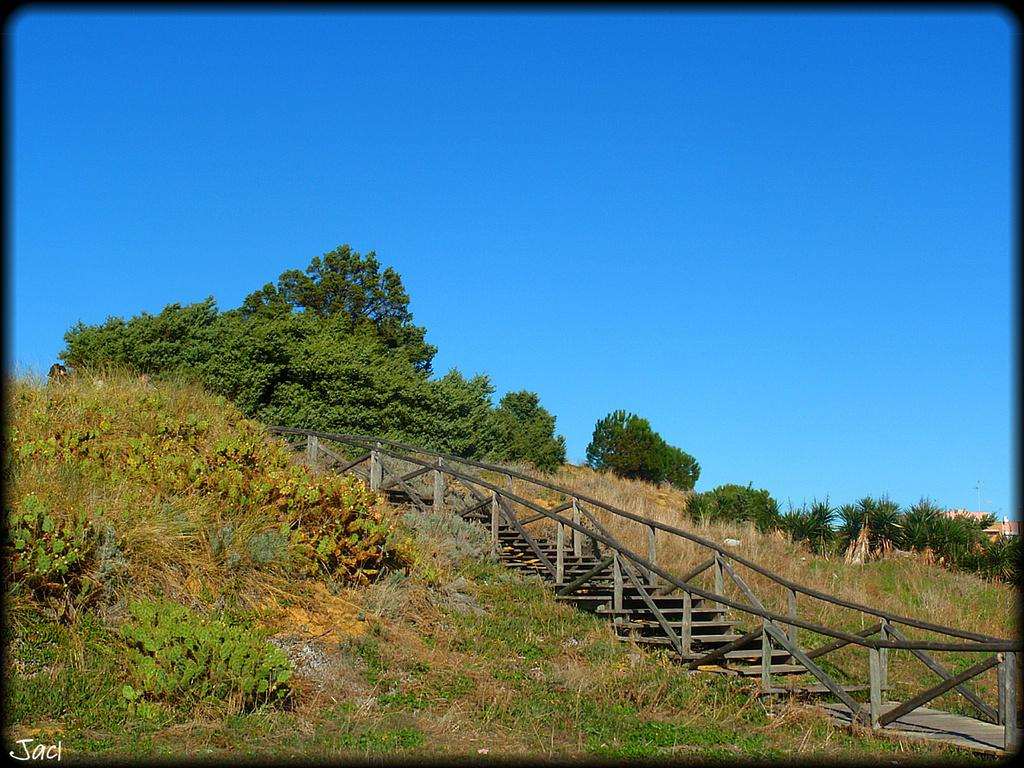What type of vegetation can be seen in the image? There are trees in the image. What else can be seen on the ground in the image? There is grass in the image. What type of structures are present in the image? There are houses in the image. Are there any architectural features visible in the image? Yes, there are stairs in the image. What is the color of the sky in the image? The sky is blue in color. What type of drum can be seen in the image? There is no drum present in the image. Is there any powder visible in the image? There is no powder visible in the image. 